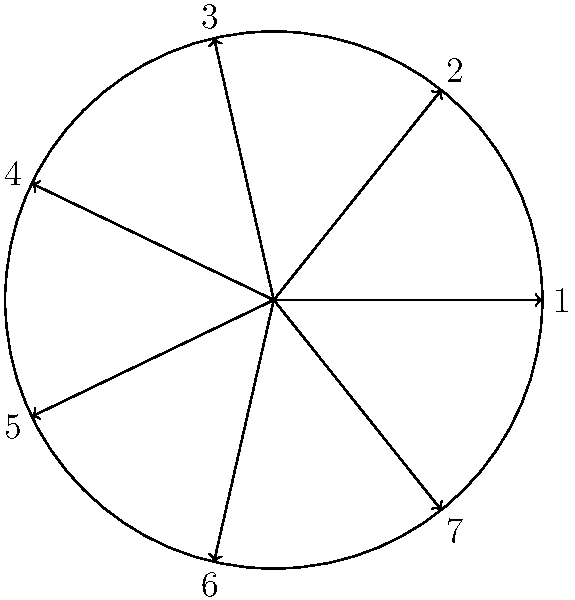As a graphic designer, you've been tasked with creating a unique clock face for an avant-garde art exhibition. The client wants a clock with 7 equally spaced divisions instead of the standard 12. If the clock has a radius of 15 cm, what is the length of the arc between two adjacent hour marks, rounded to the nearest millimeter? Let's approach this step-by-step:

1) In a circle, the total angle is $2\pi$ radians or 360°.

2) With 7 divisions, each division will span an angle of $\frac{2\pi}{7}$ radians.

3) The formula for arc length is: $s = r\theta$, where
   $s$ = arc length
   $r$ = radius
   $\theta$ = angle in radians

4) We know:
   $r = 15$ cm
   $\theta = \frac{2\pi}{7}$ radians

5) Plugging these into our formula:
   $s = 15 \cdot \frac{2\pi}{7}$

6) Simplifying:
   $s = \frac{30\pi}{7}$ cm

7) Using a calculator and rounding to the nearest millimeter:
   $s \approx 13.463$ cm $\approx 134.6$ mm $\approx 135$ mm

This length would create a visually interesting clock face that aligns with your aesthetic sensibilities as a graphic designer, while also providing a unique talking point for the art exhibition.
Answer: 135 mm 